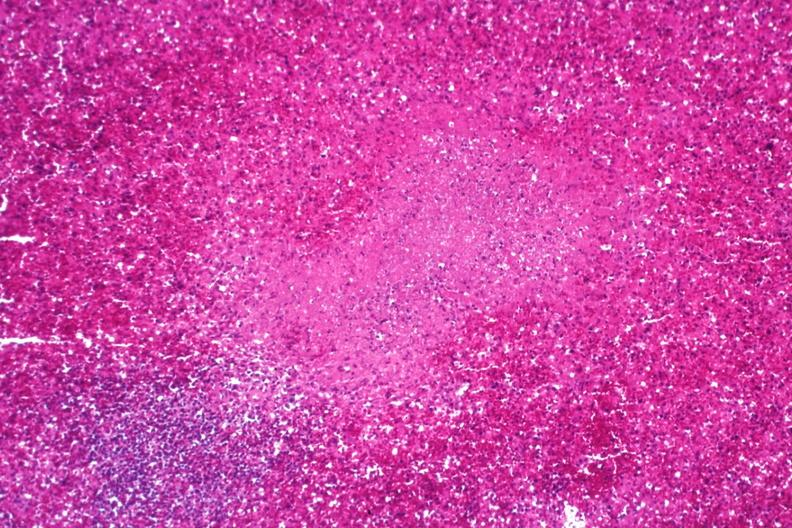s malignant histiocytosis present?
Answer the question using a single word or phrase. No 